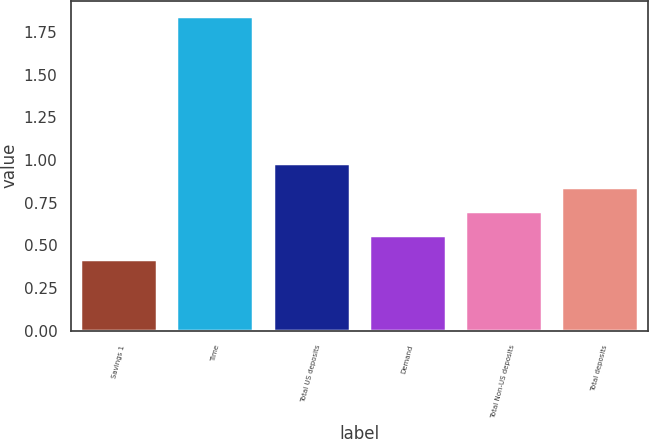<chart> <loc_0><loc_0><loc_500><loc_500><bar_chart><fcel>Savings 1<fcel>Time<fcel>Total US deposits<fcel>Demand<fcel>Total Non-US deposits<fcel>Total deposits<nl><fcel>0.42<fcel>1.84<fcel>0.98<fcel>0.56<fcel>0.7<fcel>0.84<nl></chart> 